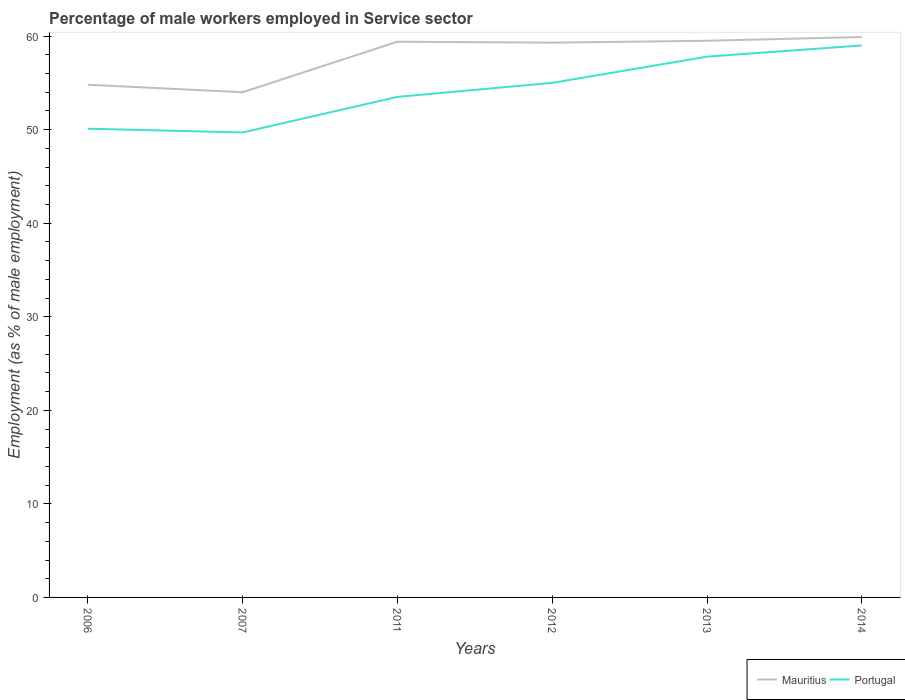How many different coloured lines are there?
Your answer should be compact. 2. Is the number of lines equal to the number of legend labels?
Your answer should be very brief. Yes. Across all years, what is the maximum percentage of male workers employed in Service sector in Portugal?
Ensure brevity in your answer.  49.7. What is the total percentage of male workers employed in Service sector in Portugal in the graph?
Offer a very short reply. -4.3. What is the difference between the highest and the second highest percentage of male workers employed in Service sector in Portugal?
Your answer should be very brief. 9.3. What is the difference between the highest and the lowest percentage of male workers employed in Service sector in Portugal?
Your answer should be compact. 3. Is the percentage of male workers employed in Service sector in Mauritius strictly greater than the percentage of male workers employed in Service sector in Portugal over the years?
Your response must be concise. No. How many lines are there?
Your response must be concise. 2. Does the graph contain any zero values?
Provide a short and direct response. No. Where does the legend appear in the graph?
Give a very brief answer. Bottom right. What is the title of the graph?
Ensure brevity in your answer.  Percentage of male workers employed in Service sector. What is the label or title of the X-axis?
Your response must be concise. Years. What is the label or title of the Y-axis?
Offer a terse response. Employment (as % of male employment). What is the Employment (as % of male employment) in Mauritius in 2006?
Offer a terse response. 54.8. What is the Employment (as % of male employment) of Portugal in 2006?
Ensure brevity in your answer.  50.1. What is the Employment (as % of male employment) of Portugal in 2007?
Give a very brief answer. 49.7. What is the Employment (as % of male employment) in Mauritius in 2011?
Make the answer very short. 59.4. What is the Employment (as % of male employment) of Portugal in 2011?
Give a very brief answer. 53.5. What is the Employment (as % of male employment) in Mauritius in 2012?
Your answer should be compact. 59.3. What is the Employment (as % of male employment) in Portugal in 2012?
Provide a short and direct response. 55. What is the Employment (as % of male employment) in Mauritius in 2013?
Offer a very short reply. 59.5. What is the Employment (as % of male employment) in Portugal in 2013?
Offer a terse response. 57.8. What is the Employment (as % of male employment) in Mauritius in 2014?
Offer a very short reply. 59.9. What is the Employment (as % of male employment) in Portugal in 2014?
Ensure brevity in your answer.  59. Across all years, what is the maximum Employment (as % of male employment) of Mauritius?
Make the answer very short. 59.9. Across all years, what is the minimum Employment (as % of male employment) in Portugal?
Your answer should be compact. 49.7. What is the total Employment (as % of male employment) of Mauritius in the graph?
Keep it short and to the point. 346.9. What is the total Employment (as % of male employment) of Portugal in the graph?
Provide a succinct answer. 325.1. What is the difference between the Employment (as % of male employment) of Portugal in 2006 and that in 2007?
Your answer should be compact. 0.4. What is the difference between the Employment (as % of male employment) of Mauritius in 2006 and that in 2011?
Offer a very short reply. -4.6. What is the difference between the Employment (as % of male employment) in Portugal in 2006 and that in 2011?
Offer a terse response. -3.4. What is the difference between the Employment (as % of male employment) in Mauritius in 2006 and that in 2012?
Your response must be concise. -4.5. What is the difference between the Employment (as % of male employment) in Portugal in 2006 and that in 2013?
Your answer should be compact. -7.7. What is the difference between the Employment (as % of male employment) of Mauritius in 2006 and that in 2014?
Your response must be concise. -5.1. What is the difference between the Employment (as % of male employment) of Portugal in 2006 and that in 2014?
Give a very brief answer. -8.9. What is the difference between the Employment (as % of male employment) of Mauritius in 2007 and that in 2011?
Your answer should be compact. -5.4. What is the difference between the Employment (as % of male employment) in Portugal in 2007 and that in 2011?
Provide a succinct answer. -3.8. What is the difference between the Employment (as % of male employment) of Mauritius in 2007 and that in 2012?
Keep it short and to the point. -5.3. What is the difference between the Employment (as % of male employment) in Portugal in 2007 and that in 2012?
Offer a very short reply. -5.3. What is the difference between the Employment (as % of male employment) in Mauritius in 2007 and that in 2013?
Ensure brevity in your answer.  -5.5. What is the difference between the Employment (as % of male employment) of Portugal in 2011 and that in 2012?
Your response must be concise. -1.5. What is the difference between the Employment (as % of male employment) in Mauritius in 2011 and that in 2013?
Give a very brief answer. -0.1. What is the difference between the Employment (as % of male employment) of Mauritius in 2011 and that in 2014?
Give a very brief answer. -0.5. What is the difference between the Employment (as % of male employment) in Mauritius in 2012 and that in 2013?
Keep it short and to the point. -0.2. What is the difference between the Employment (as % of male employment) in Portugal in 2012 and that in 2013?
Give a very brief answer. -2.8. What is the difference between the Employment (as % of male employment) of Mauritius in 2013 and that in 2014?
Offer a very short reply. -0.4. What is the difference between the Employment (as % of male employment) of Mauritius in 2006 and the Employment (as % of male employment) of Portugal in 2012?
Ensure brevity in your answer.  -0.2. What is the difference between the Employment (as % of male employment) of Mauritius in 2006 and the Employment (as % of male employment) of Portugal in 2014?
Ensure brevity in your answer.  -4.2. What is the difference between the Employment (as % of male employment) in Mauritius in 2007 and the Employment (as % of male employment) in Portugal in 2011?
Provide a succinct answer. 0.5. What is the difference between the Employment (as % of male employment) of Mauritius in 2007 and the Employment (as % of male employment) of Portugal in 2013?
Your response must be concise. -3.8. What is the difference between the Employment (as % of male employment) of Mauritius in 2011 and the Employment (as % of male employment) of Portugal in 2012?
Offer a terse response. 4.4. What is the difference between the Employment (as % of male employment) of Mauritius in 2011 and the Employment (as % of male employment) of Portugal in 2013?
Keep it short and to the point. 1.6. What is the difference between the Employment (as % of male employment) in Mauritius in 2012 and the Employment (as % of male employment) in Portugal in 2013?
Keep it short and to the point. 1.5. What is the difference between the Employment (as % of male employment) in Mauritius in 2012 and the Employment (as % of male employment) in Portugal in 2014?
Offer a terse response. 0.3. What is the difference between the Employment (as % of male employment) in Mauritius in 2013 and the Employment (as % of male employment) in Portugal in 2014?
Provide a succinct answer. 0.5. What is the average Employment (as % of male employment) in Mauritius per year?
Give a very brief answer. 57.82. What is the average Employment (as % of male employment) of Portugal per year?
Provide a short and direct response. 54.18. In the year 2007, what is the difference between the Employment (as % of male employment) of Mauritius and Employment (as % of male employment) of Portugal?
Make the answer very short. 4.3. In the year 2011, what is the difference between the Employment (as % of male employment) of Mauritius and Employment (as % of male employment) of Portugal?
Provide a short and direct response. 5.9. In the year 2014, what is the difference between the Employment (as % of male employment) of Mauritius and Employment (as % of male employment) of Portugal?
Offer a terse response. 0.9. What is the ratio of the Employment (as % of male employment) in Mauritius in 2006 to that in 2007?
Ensure brevity in your answer.  1.01. What is the ratio of the Employment (as % of male employment) in Mauritius in 2006 to that in 2011?
Offer a very short reply. 0.92. What is the ratio of the Employment (as % of male employment) in Portugal in 2006 to that in 2011?
Provide a short and direct response. 0.94. What is the ratio of the Employment (as % of male employment) of Mauritius in 2006 to that in 2012?
Your response must be concise. 0.92. What is the ratio of the Employment (as % of male employment) in Portugal in 2006 to that in 2012?
Make the answer very short. 0.91. What is the ratio of the Employment (as % of male employment) of Mauritius in 2006 to that in 2013?
Keep it short and to the point. 0.92. What is the ratio of the Employment (as % of male employment) of Portugal in 2006 to that in 2013?
Ensure brevity in your answer.  0.87. What is the ratio of the Employment (as % of male employment) of Mauritius in 2006 to that in 2014?
Give a very brief answer. 0.91. What is the ratio of the Employment (as % of male employment) in Portugal in 2006 to that in 2014?
Your response must be concise. 0.85. What is the ratio of the Employment (as % of male employment) of Portugal in 2007 to that in 2011?
Offer a very short reply. 0.93. What is the ratio of the Employment (as % of male employment) of Mauritius in 2007 to that in 2012?
Keep it short and to the point. 0.91. What is the ratio of the Employment (as % of male employment) in Portugal in 2007 to that in 2012?
Provide a succinct answer. 0.9. What is the ratio of the Employment (as % of male employment) of Mauritius in 2007 to that in 2013?
Your answer should be compact. 0.91. What is the ratio of the Employment (as % of male employment) in Portugal in 2007 to that in 2013?
Your response must be concise. 0.86. What is the ratio of the Employment (as % of male employment) in Mauritius in 2007 to that in 2014?
Offer a very short reply. 0.9. What is the ratio of the Employment (as % of male employment) in Portugal in 2007 to that in 2014?
Keep it short and to the point. 0.84. What is the ratio of the Employment (as % of male employment) of Portugal in 2011 to that in 2012?
Your response must be concise. 0.97. What is the ratio of the Employment (as % of male employment) in Portugal in 2011 to that in 2013?
Provide a short and direct response. 0.93. What is the ratio of the Employment (as % of male employment) in Mauritius in 2011 to that in 2014?
Your answer should be compact. 0.99. What is the ratio of the Employment (as % of male employment) in Portugal in 2011 to that in 2014?
Provide a short and direct response. 0.91. What is the ratio of the Employment (as % of male employment) in Mauritius in 2012 to that in 2013?
Offer a terse response. 1. What is the ratio of the Employment (as % of male employment) in Portugal in 2012 to that in 2013?
Your answer should be compact. 0.95. What is the ratio of the Employment (as % of male employment) of Mauritius in 2012 to that in 2014?
Make the answer very short. 0.99. What is the ratio of the Employment (as % of male employment) in Portugal in 2012 to that in 2014?
Offer a very short reply. 0.93. What is the ratio of the Employment (as % of male employment) in Portugal in 2013 to that in 2014?
Your answer should be very brief. 0.98. What is the difference between the highest and the second highest Employment (as % of male employment) in Mauritius?
Make the answer very short. 0.4. What is the difference between the highest and the second highest Employment (as % of male employment) in Portugal?
Offer a terse response. 1.2. What is the difference between the highest and the lowest Employment (as % of male employment) in Portugal?
Your response must be concise. 9.3. 